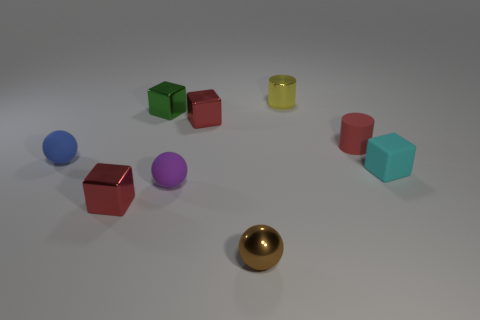Does the tiny purple matte thing have the same shape as the tiny brown metal object right of the blue sphere?
Give a very brief answer. Yes. The object that is on the right side of the small cylinder that is right of the tiny yellow metallic cylinder is made of what material?
Ensure brevity in your answer.  Rubber. Are there the same number of tiny red cylinders that are behind the metallic cylinder and small brown things?
Your answer should be very brief. No. There is a small shiny block in front of the blue ball; is it the same color as the rubber sphere to the right of the blue matte thing?
Your answer should be very brief. No. How many blocks are both in front of the tiny green metal thing and on the left side of the purple rubber ball?
Give a very brief answer. 1. How many other things are the same shape as the small purple matte thing?
Provide a short and direct response. 2. Are there more tiny red things that are to the left of the rubber cylinder than large yellow cylinders?
Provide a short and direct response. Yes. What color is the small block in front of the tiny purple matte sphere?
Make the answer very short. Red. What number of rubber things are small red objects or tiny red cubes?
Offer a very short reply. 1. There is a small ball on the right side of the small red metallic object behind the tiny blue rubber sphere; are there any small red blocks that are left of it?
Offer a terse response. Yes. 